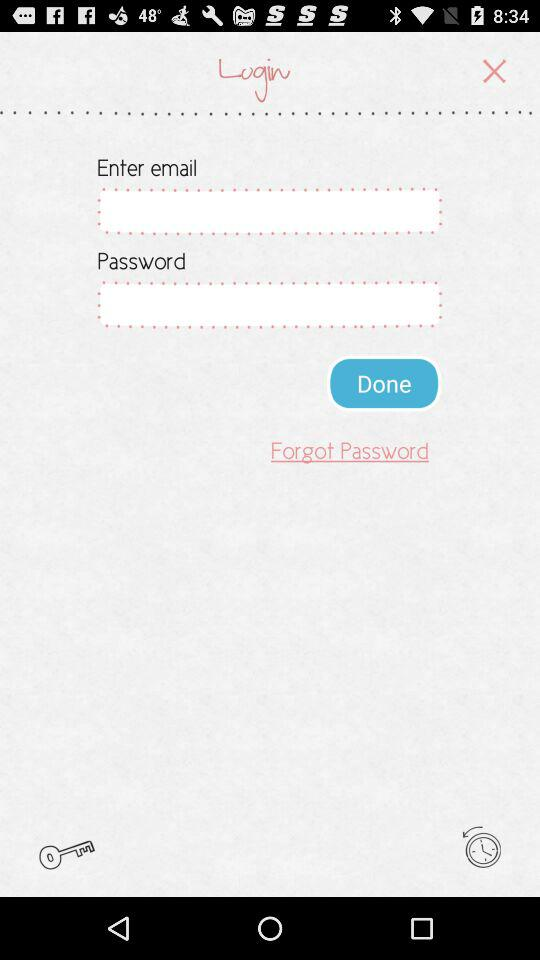How many text fields are there?
Answer the question using a single word or phrase. 2 